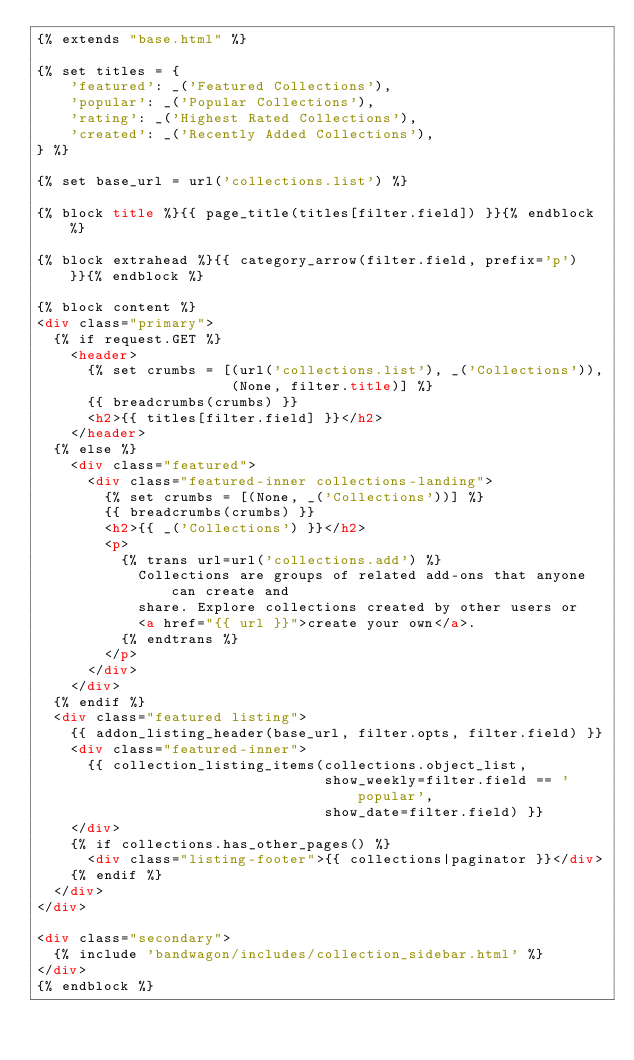<code> <loc_0><loc_0><loc_500><loc_500><_HTML_>{% extends "base.html" %}

{% set titles = {
    'featured': _('Featured Collections'),
    'popular': _('Popular Collections'),
    'rating': _('Highest Rated Collections'),
    'created': _('Recently Added Collections'),
} %}

{% set base_url = url('collections.list') %}

{% block title %}{{ page_title(titles[filter.field]) }}{% endblock %}

{% block extrahead %}{{ category_arrow(filter.field, prefix='p') }}{% endblock %}

{% block content %}
<div class="primary">
  {% if request.GET %}
    <header>
      {% set crumbs = [(url('collections.list'), _('Collections')),
                       (None, filter.title)] %}
      {{ breadcrumbs(crumbs) }}
      <h2>{{ titles[filter.field] }}</h2>
    </header>
  {% else %}
    <div class="featured">
      <div class="featured-inner collections-landing">
        {% set crumbs = [(None, _('Collections'))] %}
        {{ breadcrumbs(crumbs) }}
        <h2>{{ _('Collections') }}</h2>
        <p>
          {% trans url=url('collections.add') %}
            Collections are groups of related add-ons that anyone can create and
            share. Explore collections created by other users or
            <a href="{{ url }}">create your own</a>.
          {% endtrans %}
        </p>
      </div>
    </div>
  {% endif %}
  <div class="featured listing">
    {{ addon_listing_header(base_url, filter.opts, filter.field) }}
    <div class="featured-inner">
      {{ collection_listing_items(collections.object_list,
                                  show_weekly=filter.field == 'popular',
                                  show_date=filter.field) }}
    </div>
    {% if collections.has_other_pages() %}
      <div class="listing-footer">{{ collections|paginator }}</div>
    {% endif %}
  </div>
</div>

<div class="secondary">
  {% include 'bandwagon/includes/collection_sidebar.html' %}
</div>
{% endblock %}
</code> 